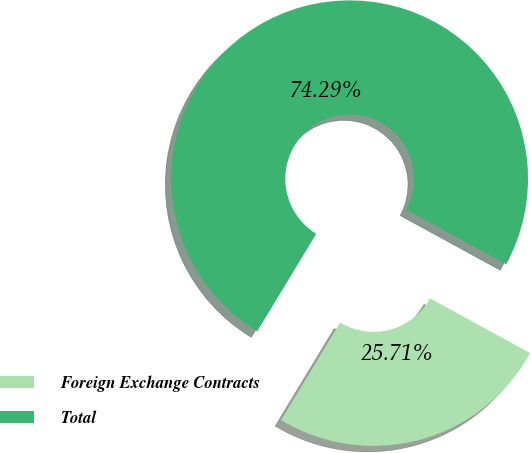Convert chart. <chart><loc_0><loc_0><loc_500><loc_500><pie_chart><fcel>Foreign Exchange Contracts<fcel>Total<nl><fcel>25.71%<fcel>74.29%<nl></chart> 